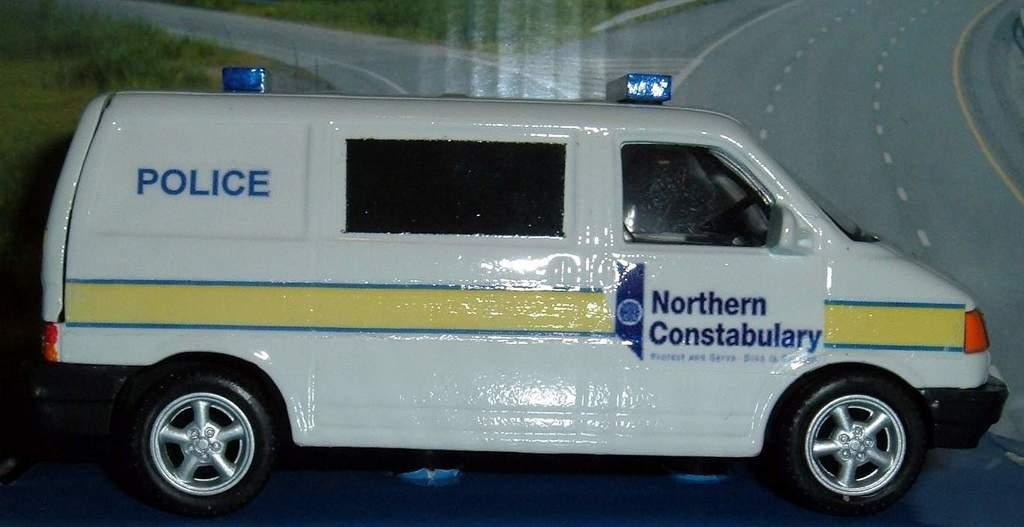<image>
Relay a brief, clear account of the picture shown. A police van has the words Northern Constabulary on the door. 